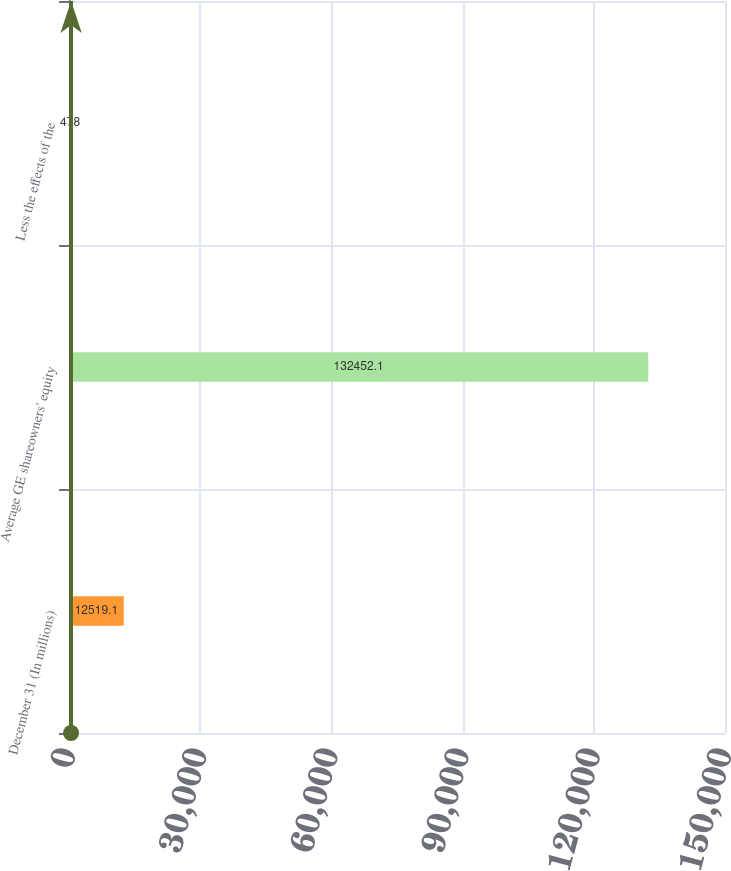Convert chart. <chart><loc_0><loc_0><loc_500><loc_500><bar_chart><fcel>December 31 (In millions)<fcel>Average GE shareowners' equity<fcel>Less the effects of the<nl><fcel>12519.1<fcel>132452<fcel>478<nl></chart> 